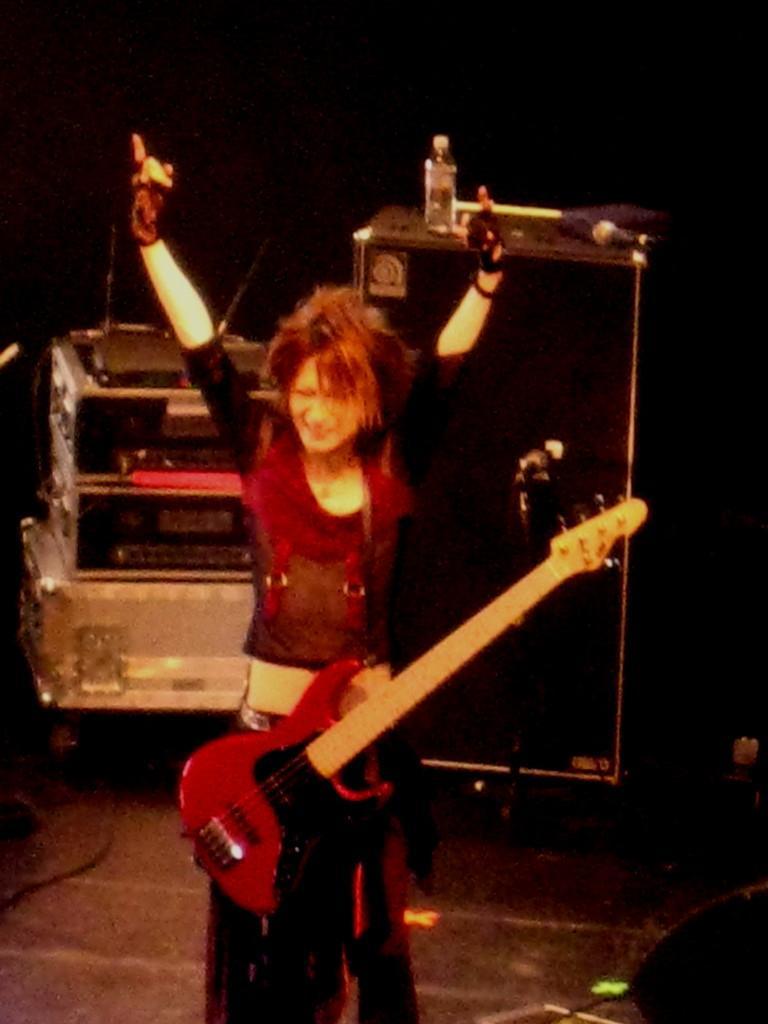Describe this image in one or two sentences. In this image I can see a woman is standing and she is carrying a guitar. In the background I can see a water bottle and a speaker. 